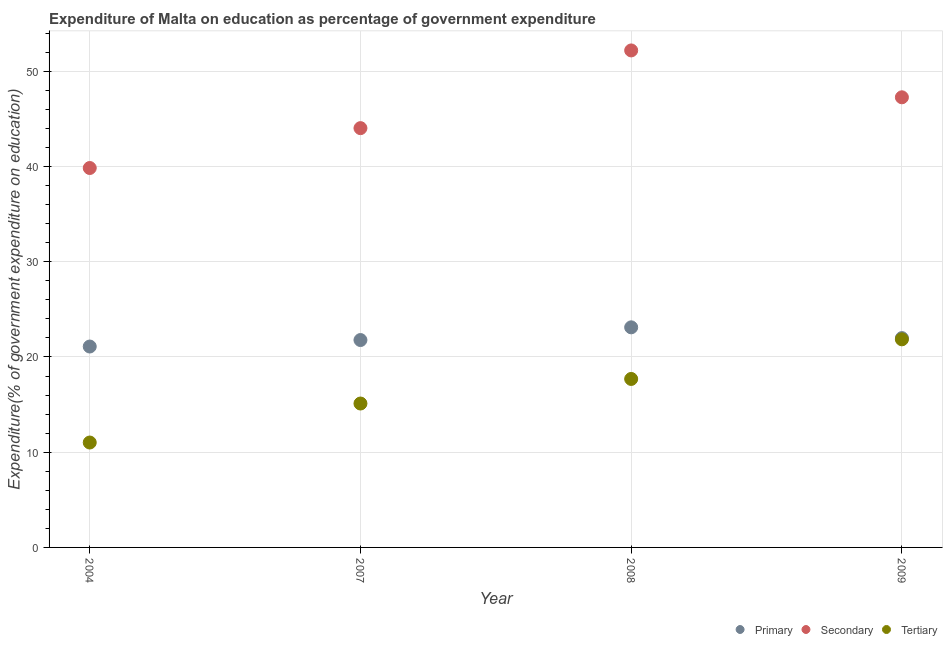How many different coloured dotlines are there?
Give a very brief answer. 3. Is the number of dotlines equal to the number of legend labels?
Your answer should be very brief. Yes. What is the expenditure on secondary education in 2008?
Keep it short and to the point. 52.2. Across all years, what is the maximum expenditure on secondary education?
Your answer should be compact. 52.2. Across all years, what is the minimum expenditure on tertiary education?
Provide a short and direct response. 11.02. In which year was the expenditure on tertiary education maximum?
Provide a short and direct response. 2009. What is the total expenditure on secondary education in the graph?
Ensure brevity in your answer.  183.35. What is the difference between the expenditure on tertiary education in 2004 and that in 2008?
Provide a short and direct response. -6.68. What is the difference between the expenditure on tertiary education in 2007 and the expenditure on primary education in 2004?
Keep it short and to the point. -5.99. What is the average expenditure on tertiary education per year?
Your answer should be compact. 16.42. In the year 2004, what is the difference between the expenditure on tertiary education and expenditure on secondary education?
Offer a very short reply. -28.83. In how many years, is the expenditure on tertiary education greater than 42 %?
Your answer should be compact. 0. What is the ratio of the expenditure on secondary education in 2004 to that in 2007?
Offer a very short reply. 0.9. Is the difference between the expenditure on tertiary education in 2004 and 2009 greater than the difference between the expenditure on primary education in 2004 and 2009?
Your answer should be very brief. No. What is the difference between the highest and the second highest expenditure on primary education?
Make the answer very short. 1.13. What is the difference between the highest and the lowest expenditure on primary education?
Give a very brief answer. 2.02. Is the sum of the expenditure on primary education in 2004 and 2008 greater than the maximum expenditure on tertiary education across all years?
Your response must be concise. Yes. Is the expenditure on primary education strictly greater than the expenditure on tertiary education over the years?
Keep it short and to the point. Yes. How many dotlines are there?
Give a very brief answer. 3. What is the difference between two consecutive major ticks on the Y-axis?
Offer a terse response. 10. Does the graph contain grids?
Provide a succinct answer. Yes. What is the title of the graph?
Make the answer very short. Expenditure of Malta on education as percentage of government expenditure. What is the label or title of the Y-axis?
Offer a very short reply. Expenditure(% of government expenditure on education). What is the Expenditure(% of government expenditure on education) in Primary in 2004?
Provide a short and direct response. 21.1. What is the Expenditure(% of government expenditure on education) of Secondary in 2004?
Give a very brief answer. 39.85. What is the Expenditure(% of government expenditure on education) in Tertiary in 2004?
Provide a short and direct response. 11.02. What is the Expenditure(% of government expenditure on education) of Primary in 2007?
Ensure brevity in your answer.  21.78. What is the Expenditure(% of government expenditure on education) of Secondary in 2007?
Your response must be concise. 44.03. What is the Expenditure(% of government expenditure on education) in Tertiary in 2007?
Ensure brevity in your answer.  15.11. What is the Expenditure(% of government expenditure on education) in Primary in 2008?
Your response must be concise. 23.11. What is the Expenditure(% of government expenditure on education) of Secondary in 2008?
Offer a terse response. 52.2. What is the Expenditure(% of government expenditure on education) of Tertiary in 2008?
Offer a very short reply. 17.69. What is the Expenditure(% of government expenditure on education) of Primary in 2009?
Ensure brevity in your answer.  21.98. What is the Expenditure(% of government expenditure on education) of Secondary in 2009?
Your answer should be very brief. 47.27. What is the Expenditure(% of government expenditure on education) in Tertiary in 2009?
Your answer should be very brief. 21.85. Across all years, what is the maximum Expenditure(% of government expenditure on education) in Primary?
Provide a succinct answer. 23.11. Across all years, what is the maximum Expenditure(% of government expenditure on education) of Secondary?
Make the answer very short. 52.2. Across all years, what is the maximum Expenditure(% of government expenditure on education) of Tertiary?
Offer a terse response. 21.85. Across all years, what is the minimum Expenditure(% of government expenditure on education) of Primary?
Make the answer very short. 21.1. Across all years, what is the minimum Expenditure(% of government expenditure on education) in Secondary?
Provide a succinct answer. 39.85. Across all years, what is the minimum Expenditure(% of government expenditure on education) in Tertiary?
Your response must be concise. 11.02. What is the total Expenditure(% of government expenditure on education) of Primary in the graph?
Offer a terse response. 87.98. What is the total Expenditure(% of government expenditure on education) of Secondary in the graph?
Your answer should be very brief. 183.35. What is the total Expenditure(% of government expenditure on education) of Tertiary in the graph?
Provide a succinct answer. 65.68. What is the difference between the Expenditure(% of government expenditure on education) of Primary in 2004 and that in 2007?
Ensure brevity in your answer.  -0.68. What is the difference between the Expenditure(% of government expenditure on education) of Secondary in 2004 and that in 2007?
Your answer should be very brief. -4.19. What is the difference between the Expenditure(% of government expenditure on education) of Tertiary in 2004 and that in 2007?
Offer a terse response. -4.1. What is the difference between the Expenditure(% of government expenditure on education) in Primary in 2004 and that in 2008?
Keep it short and to the point. -2.02. What is the difference between the Expenditure(% of government expenditure on education) of Secondary in 2004 and that in 2008?
Provide a succinct answer. -12.35. What is the difference between the Expenditure(% of government expenditure on education) of Tertiary in 2004 and that in 2008?
Ensure brevity in your answer.  -6.68. What is the difference between the Expenditure(% of government expenditure on education) of Primary in 2004 and that in 2009?
Your answer should be compact. -0.88. What is the difference between the Expenditure(% of government expenditure on education) in Secondary in 2004 and that in 2009?
Your response must be concise. -7.43. What is the difference between the Expenditure(% of government expenditure on education) in Tertiary in 2004 and that in 2009?
Your answer should be very brief. -10.84. What is the difference between the Expenditure(% of government expenditure on education) of Primary in 2007 and that in 2008?
Provide a succinct answer. -1.33. What is the difference between the Expenditure(% of government expenditure on education) of Secondary in 2007 and that in 2008?
Your answer should be very brief. -8.16. What is the difference between the Expenditure(% of government expenditure on education) of Tertiary in 2007 and that in 2008?
Your answer should be very brief. -2.58. What is the difference between the Expenditure(% of government expenditure on education) in Primary in 2007 and that in 2009?
Your response must be concise. -0.2. What is the difference between the Expenditure(% of government expenditure on education) of Secondary in 2007 and that in 2009?
Keep it short and to the point. -3.24. What is the difference between the Expenditure(% of government expenditure on education) of Tertiary in 2007 and that in 2009?
Provide a succinct answer. -6.74. What is the difference between the Expenditure(% of government expenditure on education) of Primary in 2008 and that in 2009?
Ensure brevity in your answer.  1.13. What is the difference between the Expenditure(% of government expenditure on education) of Secondary in 2008 and that in 2009?
Your answer should be compact. 4.92. What is the difference between the Expenditure(% of government expenditure on education) of Tertiary in 2008 and that in 2009?
Give a very brief answer. -4.16. What is the difference between the Expenditure(% of government expenditure on education) of Primary in 2004 and the Expenditure(% of government expenditure on education) of Secondary in 2007?
Provide a short and direct response. -22.94. What is the difference between the Expenditure(% of government expenditure on education) of Primary in 2004 and the Expenditure(% of government expenditure on education) of Tertiary in 2007?
Provide a succinct answer. 5.99. What is the difference between the Expenditure(% of government expenditure on education) in Secondary in 2004 and the Expenditure(% of government expenditure on education) in Tertiary in 2007?
Your answer should be compact. 24.73. What is the difference between the Expenditure(% of government expenditure on education) in Primary in 2004 and the Expenditure(% of government expenditure on education) in Secondary in 2008?
Provide a succinct answer. -31.1. What is the difference between the Expenditure(% of government expenditure on education) in Primary in 2004 and the Expenditure(% of government expenditure on education) in Tertiary in 2008?
Keep it short and to the point. 3.41. What is the difference between the Expenditure(% of government expenditure on education) of Secondary in 2004 and the Expenditure(% of government expenditure on education) of Tertiary in 2008?
Your response must be concise. 22.15. What is the difference between the Expenditure(% of government expenditure on education) of Primary in 2004 and the Expenditure(% of government expenditure on education) of Secondary in 2009?
Keep it short and to the point. -26.17. What is the difference between the Expenditure(% of government expenditure on education) in Primary in 2004 and the Expenditure(% of government expenditure on education) in Tertiary in 2009?
Offer a terse response. -0.76. What is the difference between the Expenditure(% of government expenditure on education) in Secondary in 2004 and the Expenditure(% of government expenditure on education) in Tertiary in 2009?
Make the answer very short. 17.99. What is the difference between the Expenditure(% of government expenditure on education) of Primary in 2007 and the Expenditure(% of government expenditure on education) of Secondary in 2008?
Your answer should be very brief. -30.42. What is the difference between the Expenditure(% of government expenditure on education) in Primary in 2007 and the Expenditure(% of government expenditure on education) in Tertiary in 2008?
Ensure brevity in your answer.  4.09. What is the difference between the Expenditure(% of government expenditure on education) of Secondary in 2007 and the Expenditure(% of government expenditure on education) of Tertiary in 2008?
Your answer should be very brief. 26.34. What is the difference between the Expenditure(% of government expenditure on education) of Primary in 2007 and the Expenditure(% of government expenditure on education) of Secondary in 2009?
Your answer should be very brief. -25.49. What is the difference between the Expenditure(% of government expenditure on education) in Primary in 2007 and the Expenditure(% of government expenditure on education) in Tertiary in 2009?
Offer a very short reply. -0.07. What is the difference between the Expenditure(% of government expenditure on education) of Secondary in 2007 and the Expenditure(% of government expenditure on education) of Tertiary in 2009?
Your answer should be compact. 22.18. What is the difference between the Expenditure(% of government expenditure on education) of Primary in 2008 and the Expenditure(% of government expenditure on education) of Secondary in 2009?
Offer a terse response. -24.16. What is the difference between the Expenditure(% of government expenditure on education) in Primary in 2008 and the Expenditure(% of government expenditure on education) in Tertiary in 2009?
Your response must be concise. 1.26. What is the difference between the Expenditure(% of government expenditure on education) of Secondary in 2008 and the Expenditure(% of government expenditure on education) of Tertiary in 2009?
Keep it short and to the point. 30.34. What is the average Expenditure(% of government expenditure on education) in Primary per year?
Offer a very short reply. 21.99. What is the average Expenditure(% of government expenditure on education) in Secondary per year?
Offer a terse response. 45.84. What is the average Expenditure(% of government expenditure on education) of Tertiary per year?
Your answer should be compact. 16.42. In the year 2004, what is the difference between the Expenditure(% of government expenditure on education) in Primary and Expenditure(% of government expenditure on education) in Secondary?
Provide a succinct answer. -18.75. In the year 2004, what is the difference between the Expenditure(% of government expenditure on education) of Primary and Expenditure(% of government expenditure on education) of Tertiary?
Keep it short and to the point. 10.08. In the year 2004, what is the difference between the Expenditure(% of government expenditure on education) in Secondary and Expenditure(% of government expenditure on education) in Tertiary?
Your answer should be compact. 28.83. In the year 2007, what is the difference between the Expenditure(% of government expenditure on education) in Primary and Expenditure(% of government expenditure on education) in Secondary?
Provide a succinct answer. -22.25. In the year 2007, what is the difference between the Expenditure(% of government expenditure on education) in Primary and Expenditure(% of government expenditure on education) in Tertiary?
Offer a terse response. 6.67. In the year 2007, what is the difference between the Expenditure(% of government expenditure on education) of Secondary and Expenditure(% of government expenditure on education) of Tertiary?
Provide a short and direct response. 28.92. In the year 2008, what is the difference between the Expenditure(% of government expenditure on education) of Primary and Expenditure(% of government expenditure on education) of Secondary?
Provide a succinct answer. -29.08. In the year 2008, what is the difference between the Expenditure(% of government expenditure on education) in Primary and Expenditure(% of government expenditure on education) in Tertiary?
Provide a succinct answer. 5.42. In the year 2008, what is the difference between the Expenditure(% of government expenditure on education) in Secondary and Expenditure(% of government expenditure on education) in Tertiary?
Offer a very short reply. 34.5. In the year 2009, what is the difference between the Expenditure(% of government expenditure on education) of Primary and Expenditure(% of government expenditure on education) of Secondary?
Your answer should be compact. -25.29. In the year 2009, what is the difference between the Expenditure(% of government expenditure on education) of Primary and Expenditure(% of government expenditure on education) of Tertiary?
Provide a short and direct response. 0.13. In the year 2009, what is the difference between the Expenditure(% of government expenditure on education) in Secondary and Expenditure(% of government expenditure on education) in Tertiary?
Provide a short and direct response. 25.42. What is the ratio of the Expenditure(% of government expenditure on education) of Primary in 2004 to that in 2007?
Offer a very short reply. 0.97. What is the ratio of the Expenditure(% of government expenditure on education) of Secondary in 2004 to that in 2007?
Your answer should be very brief. 0.9. What is the ratio of the Expenditure(% of government expenditure on education) in Tertiary in 2004 to that in 2007?
Keep it short and to the point. 0.73. What is the ratio of the Expenditure(% of government expenditure on education) of Primary in 2004 to that in 2008?
Provide a succinct answer. 0.91. What is the ratio of the Expenditure(% of government expenditure on education) of Secondary in 2004 to that in 2008?
Your answer should be compact. 0.76. What is the ratio of the Expenditure(% of government expenditure on education) of Tertiary in 2004 to that in 2008?
Offer a terse response. 0.62. What is the ratio of the Expenditure(% of government expenditure on education) of Primary in 2004 to that in 2009?
Keep it short and to the point. 0.96. What is the ratio of the Expenditure(% of government expenditure on education) of Secondary in 2004 to that in 2009?
Your response must be concise. 0.84. What is the ratio of the Expenditure(% of government expenditure on education) of Tertiary in 2004 to that in 2009?
Your answer should be very brief. 0.5. What is the ratio of the Expenditure(% of government expenditure on education) of Primary in 2007 to that in 2008?
Offer a very short reply. 0.94. What is the ratio of the Expenditure(% of government expenditure on education) of Secondary in 2007 to that in 2008?
Offer a terse response. 0.84. What is the ratio of the Expenditure(% of government expenditure on education) of Tertiary in 2007 to that in 2008?
Offer a very short reply. 0.85. What is the ratio of the Expenditure(% of government expenditure on education) of Primary in 2007 to that in 2009?
Offer a terse response. 0.99. What is the ratio of the Expenditure(% of government expenditure on education) of Secondary in 2007 to that in 2009?
Offer a terse response. 0.93. What is the ratio of the Expenditure(% of government expenditure on education) of Tertiary in 2007 to that in 2009?
Your answer should be very brief. 0.69. What is the ratio of the Expenditure(% of government expenditure on education) of Primary in 2008 to that in 2009?
Your response must be concise. 1.05. What is the ratio of the Expenditure(% of government expenditure on education) in Secondary in 2008 to that in 2009?
Your answer should be very brief. 1.1. What is the ratio of the Expenditure(% of government expenditure on education) in Tertiary in 2008 to that in 2009?
Give a very brief answer. 0.81. What is the difference between the highest and the second highest Expenditure(% of government expenditure on education) in Primary?
Your answer should be compact. 1.13. What is the difference between the highest and the second highest Expenditure(% of government expenditure on education) of Secondary?
Ensure brevity in your answer.  4.92. What is the difference between the highest and the second highest Expenditure(% of government expenditure on education) in Tertiary?
Ensure brevity in your answer.  4.16. What is the difference between the highest and the lowest Expenditure(% of government expenditure on education) in Primary?
Offer a terse response. 2.02. What is the difference between the highest and the lowest Expenditure(% of government expenditure on education) in Secondary?
Provide a short and direct response. 12.35. What is the difference between the highest and the lowest Expenditure(% of government expenditure on education) of Tertiary?
Ensure brevity in your answer.  10.84. 